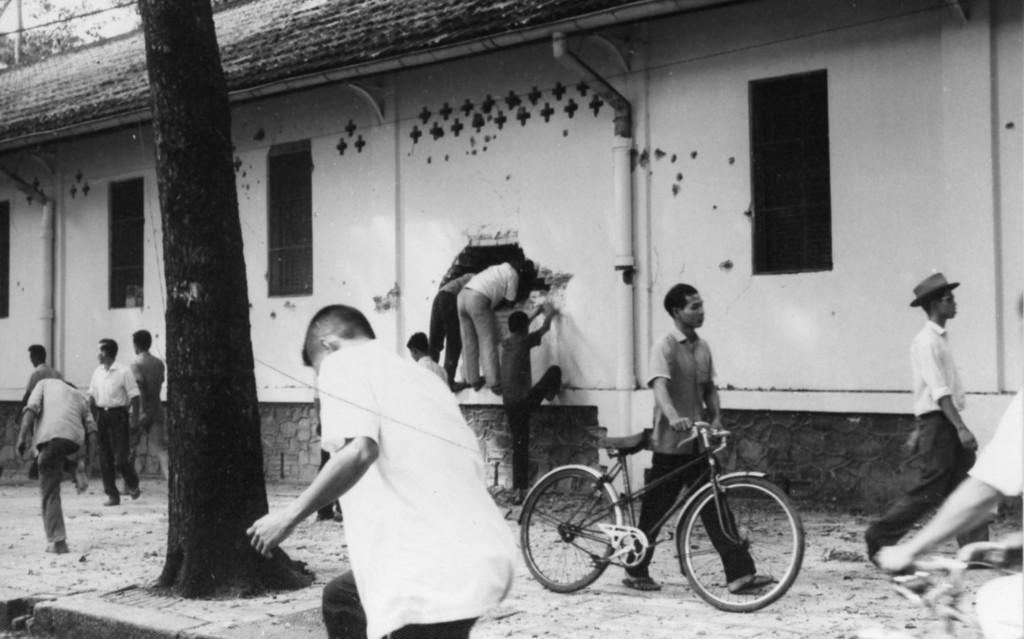Please provide a concise description of this image. This is a black and white picture. There are few people walking. This is a tree trunk. This is a building with windows. There are few people climbing the wall and peeping into the building. Here is the person holding bicycle and walking. 